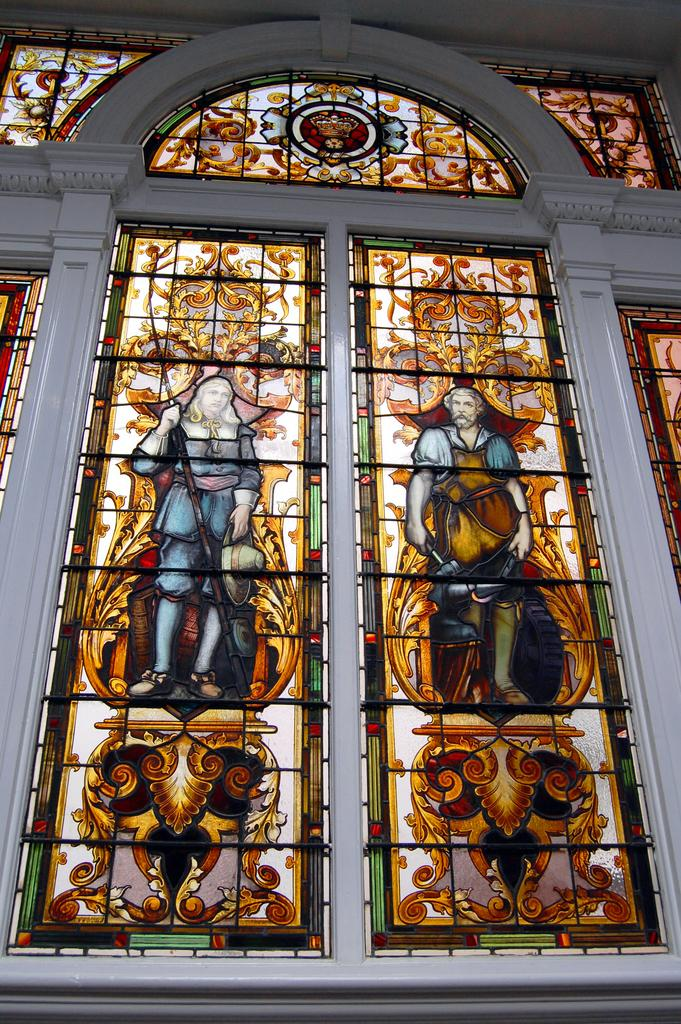What type of structure is present in the image? There is a glass window in the image. Where is the glass window located? The glass window is on a wall. What can be observed on the glass window? The glass window has designs on it. What type of hill can be seen through the glass window in the image? There is no hill visible through the glass window in the image. 